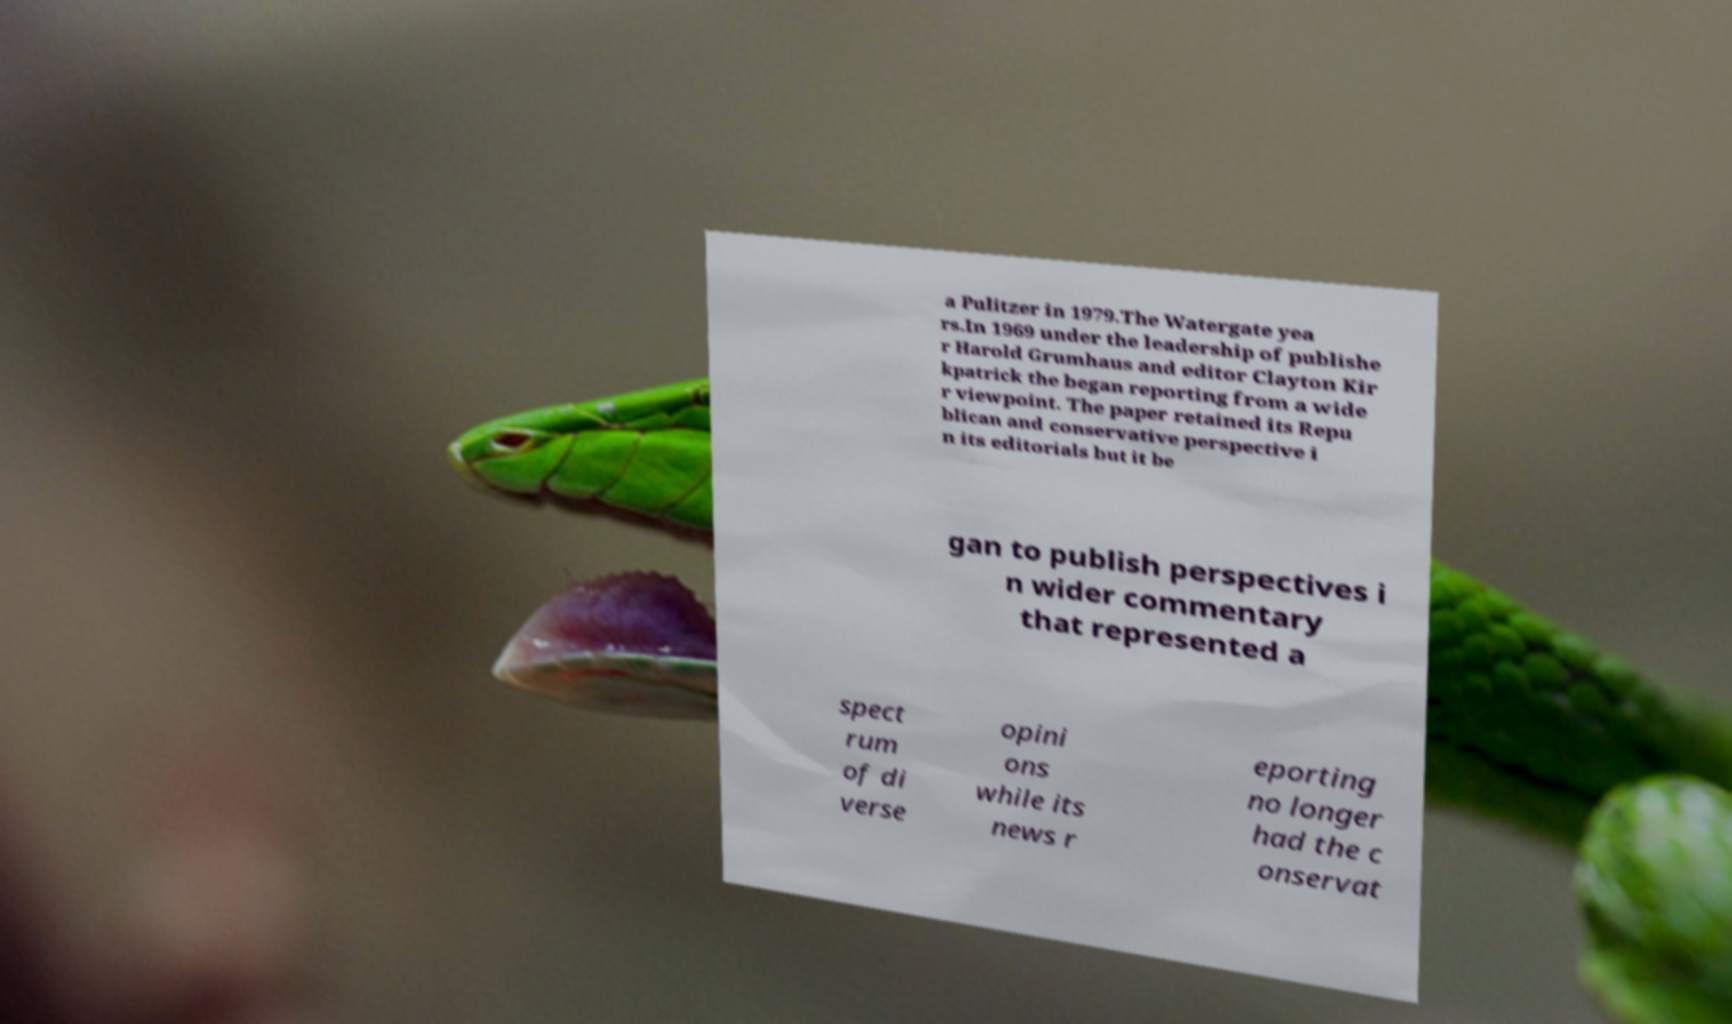Could you assist in decoding the text presented in this image and type it out clearly? a Pulitzer in 1979.The Watergate yea rs.In 1969 under the leadership of publishe r Harold Grumhaus and editor Clayton Kir kpatrick the began reporting from a wide r viewpoint. The paper retained its Repu blican and conservative perspective i n its editorials but it be gan to publish perspectives i n wider commentary that represented a spect rum of di verse opini ons while its news r eporting no longer had the c onservat 